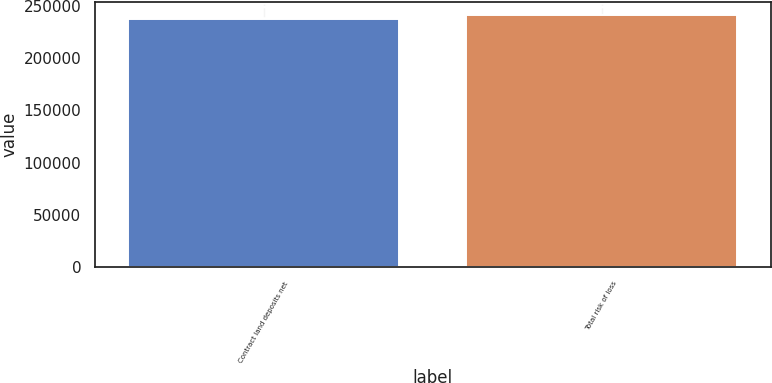Convert chart to OTSL. <chart><loc_0><loc_0><loc_500><loc_500><bar_chart><fcel>Contract land deposits net<fcel>Total risk of loss<nl><fcel>236885<fcel>241051<nl></chart> 